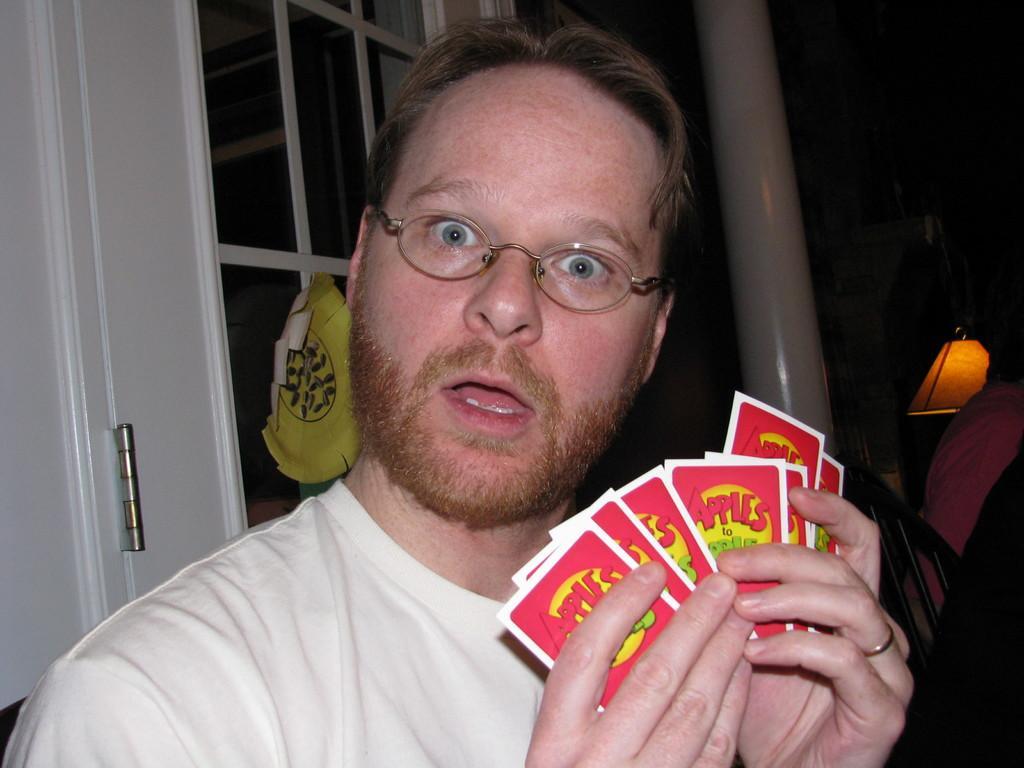How would you summarize this image in a sentence or two? In this image, we can see a man standing, he is holding some cards, in the background, we can see the window and a lamp. 